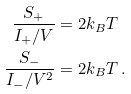<formula> <loc_0><loc_0><loc_500><loc_500>\frac { S _ { + } } { I _ { + } / V } & = 2 k _ { B } T \, \\ \frac { S _ { - } } { I _ { - } / V ^ { 2 } } & = 2 k _ { B } T \, .</formula> 